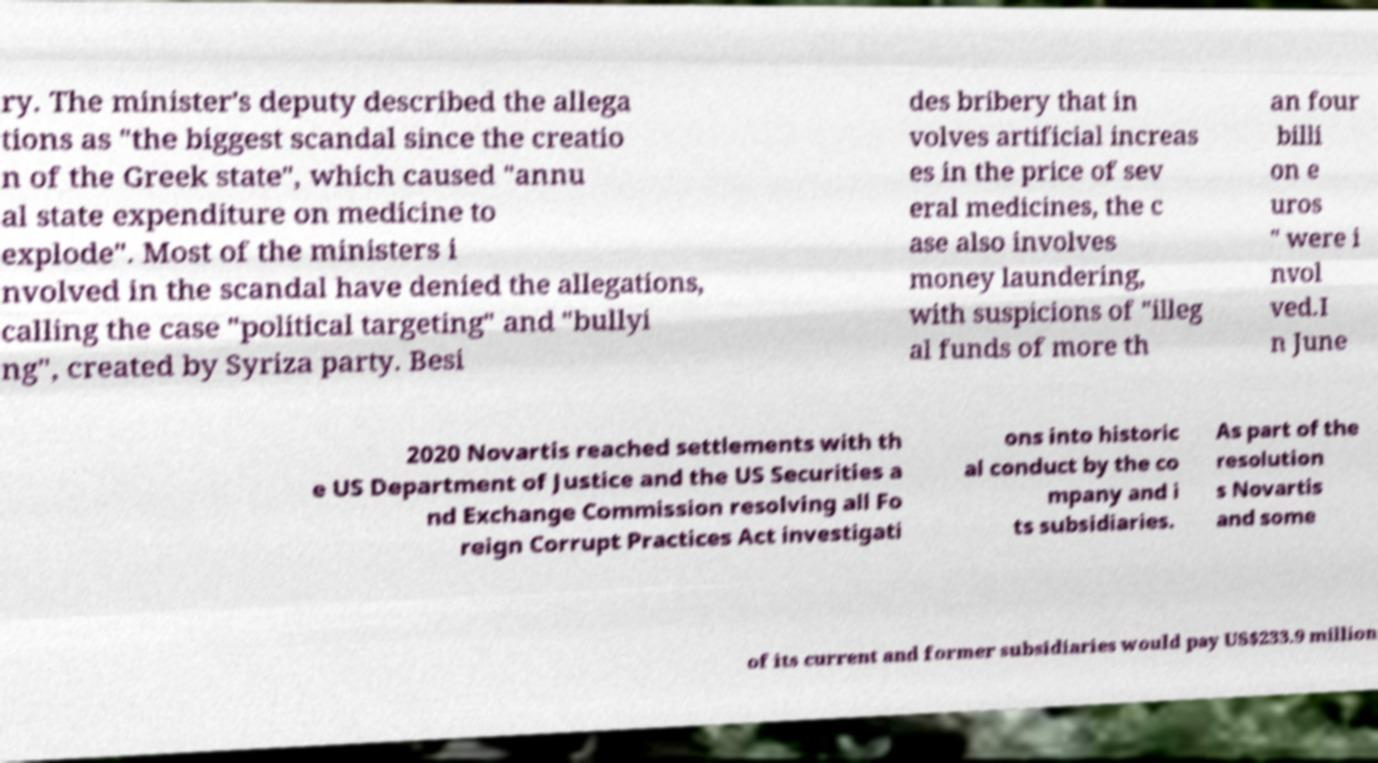Can you read and provide the text displayed in the image?This photo seems to have some interesting text. Can you extract and type it out for me? ry. The minister's deputy described the allega tions as "the biggest scandal since the creatio n of the Greek state", which caused "annu al state expenditure on medicine to explode". Most of the ministers i nvolved in the scandal have denied the allegations, calling the case "political targeting" and "bullyi ng", created by Syriza party. Besi des bribery that in volves artificial increas es in the price of sev eral medicines, the c ase also involves money laundering, with suspicions of "illeg al funds of more th an four billi on e uros " were i nvol ved.I n June 2020 Novartis reached settlements with th e US Department of Justice and the US Securities a nd Exchange Commission resolving all Fo reign Corrupt Practices Act investigati ons into historic al conduct by the co mpany and i ts subsidiaries. As part of the resolution s Novartis and some of its current and former subsidiaries would pay US$233.9 million 